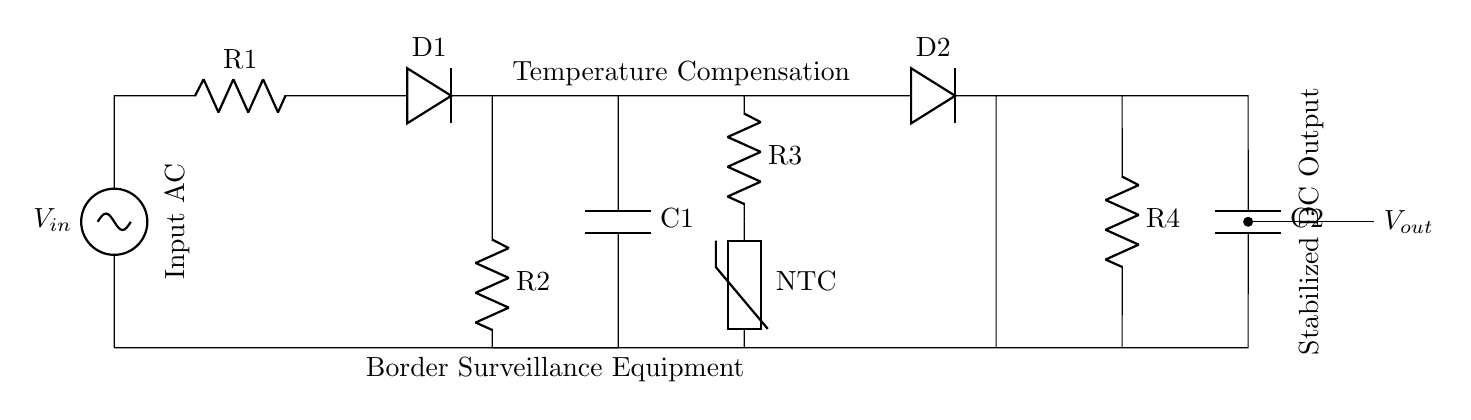What type of rectifier is shown? The circuit contains diodes, specifically two diodes labeled D1 and D2, indicating that it is a full-wave rectifier. This type converts both halves of the AC input into DC.
Answer: Full-wave rectifier How many resistors are present in the circuit? There are four resistors labeled R1, R2, R3, and R4. Thus, counting the components will reveal the total number in the circuit.
Answer: Four What is the role of the thermistor in this circuit? The thermistor, labeled as NTC, provides temperature compensation. In this circuit, it adjusts the resistance based on temperature changes, helping stabilize the output voltage throughout varying conditions.
Answer: Temperature compensation What is the output voltage of this rectifier circuit? The circuit shows a labeled output connection as Vout. Since output voltage isn't provided numerically in the diagram, it’s understood as a stabilized DC output from the rectifier. The exact value would depend on the AC input and component values, which are not specified here.
Answer: Stabilized DC output What is the purpose of capacitor C1? Capacitor C1 is used for filtering to smooth out the rectified output voltage. It stores electrical energy and releases it when the voltage dips, reducing ripple in the DC output.
Answer: Smoothing or filtering What happens to the voltage output when the temperature increases? With an increase in temperature, the resistance of the NTC thermistor decreases, which adjusts the current flow accordingly to stabilize the output voltage. This compensation helps counteract temperature-induced variations in the output.
Answer: Voltage stabilizes How is temperature compensation achieved in this circuit? Temperature compensation is achieved through the use of the NTC thermistor, which varies resistance with temperature. This change in resistance affects the current flow, thereby regulating the voltage output as temperature fluctuates.
Answer: NTC thermistor 